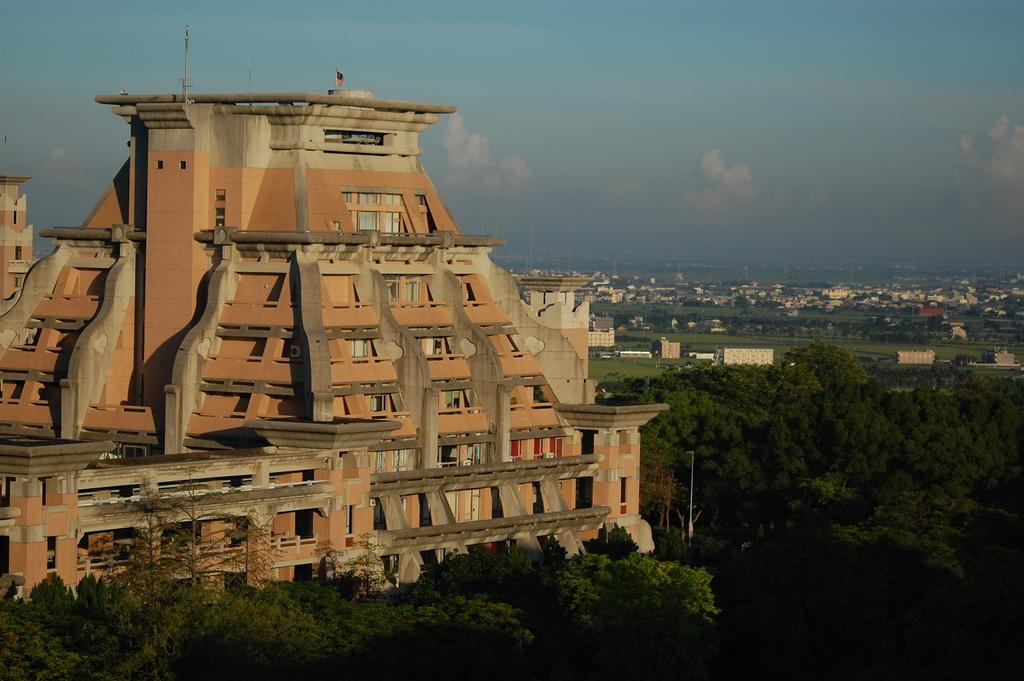What type of structures can be seen in the image? There are buildings with windows in the image. What else is present in the image besides buildings? There are poles, a flag, trees, and the sky is visible in the image. Can you describe the flag in the image? Yes, there is a flag in the image. What is visible in the sky in the image? The sky is visible in the image, and clouds are present. Where is the pot located in the image? There is no pot present in the image. Is there a volcano visible in the image? No, there is no volcano present in the image. 